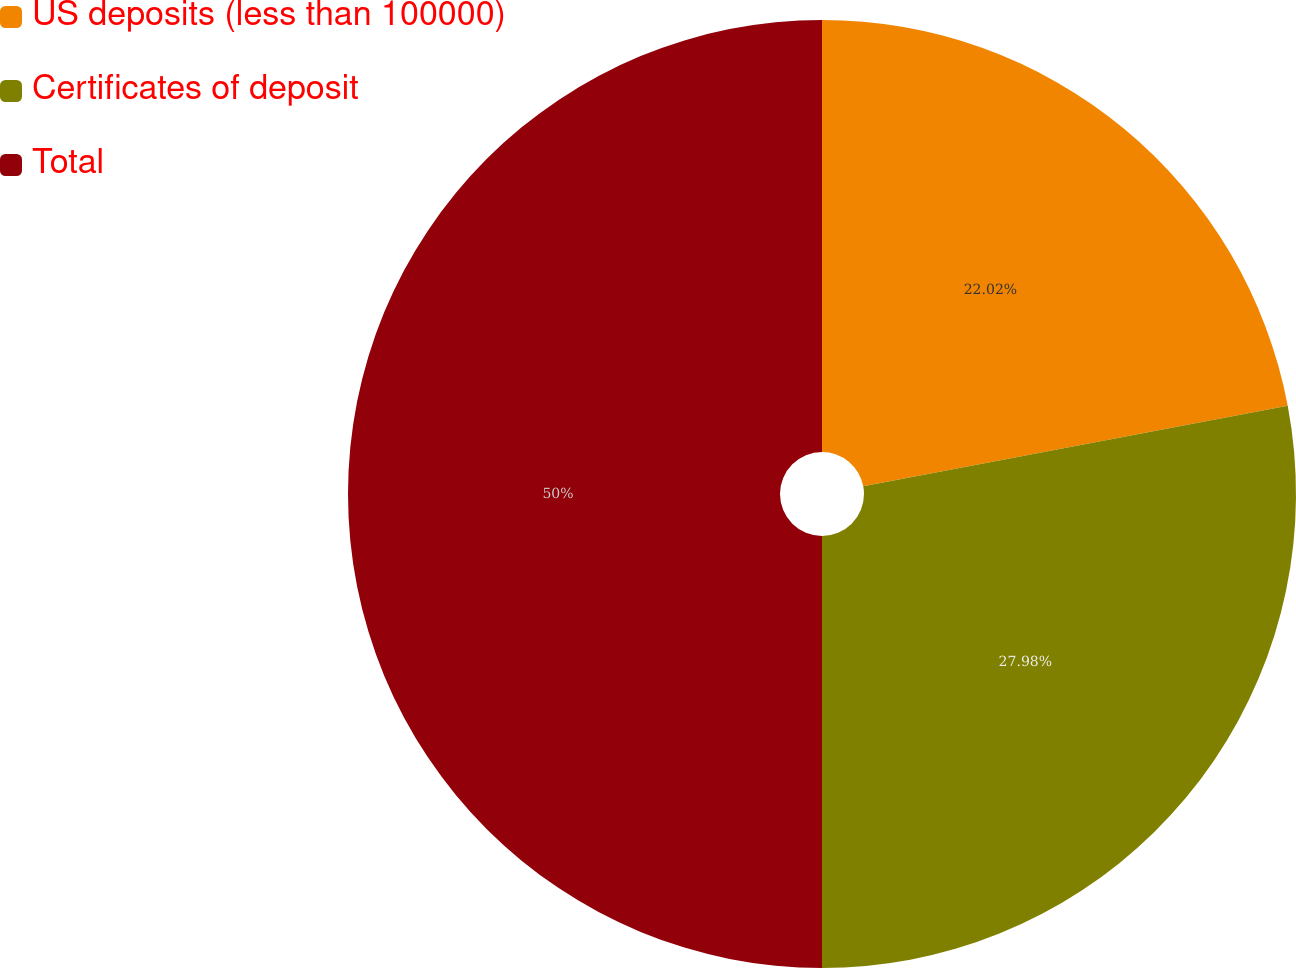Convert chart. <chart><loc_0><loc_0><loc_500><loc_500><pie_chart><fcel>US deposits (less than 100000)<fcel>Certificates of deposit<fcel>Total<nl><fcel>22.02%<fcel>27.98%<fcel>50.0%<nl></chart> 